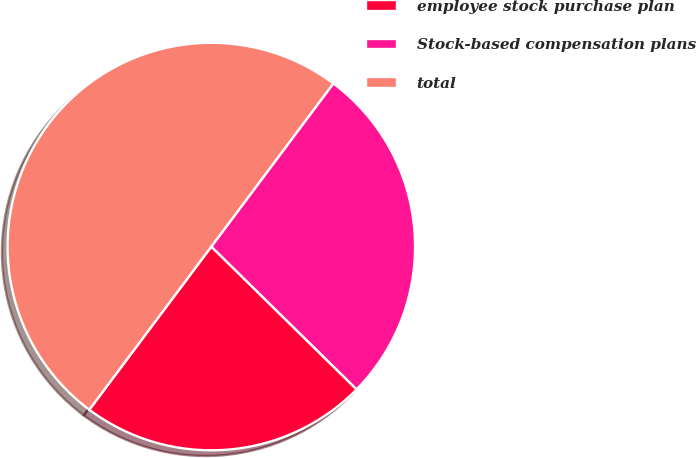Convert chart. <chart><loc_0><loc_0><loc_500><loc_500><pie_chart><fcel>employee stock purchase plan<fcel>Stock-based compensation plans<fcel>total<nl><fcel>22.86%<fcel>27.14%<fcel>50.0%<nl></chart> 